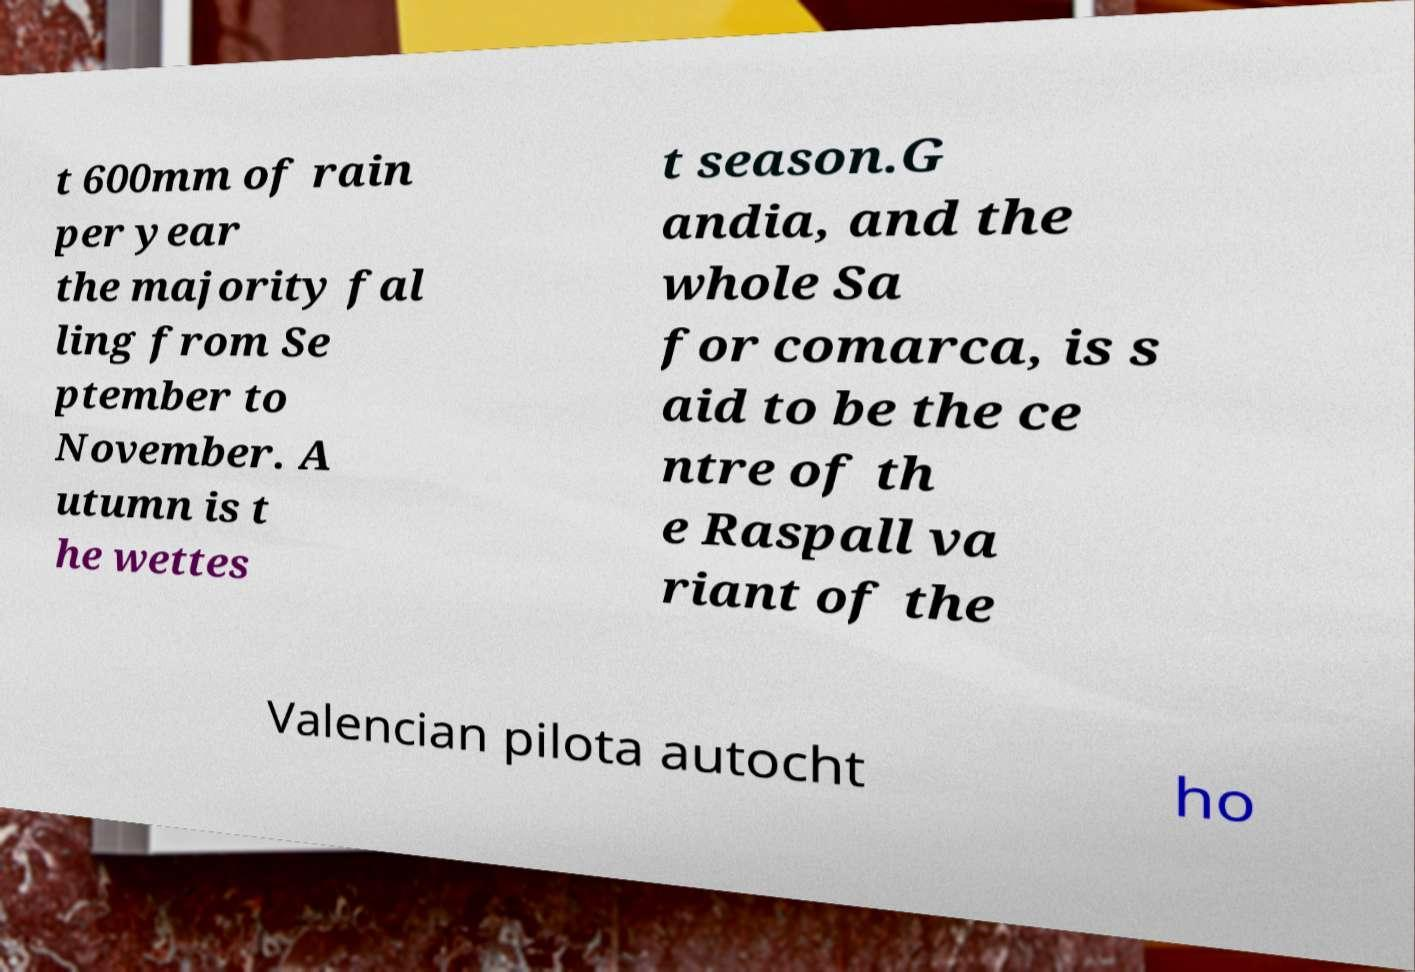Could you assist in decoding the text presented in this image and type it out clearly? t 600mm of rain per year the majority fal ling from Se ptember to November. A utumn is t he wettes t season.G andia, and the whole Sa for comarca, is s aid to be the ce ntre of th e Raspall va riant of the Valencian pilota autocht ho 